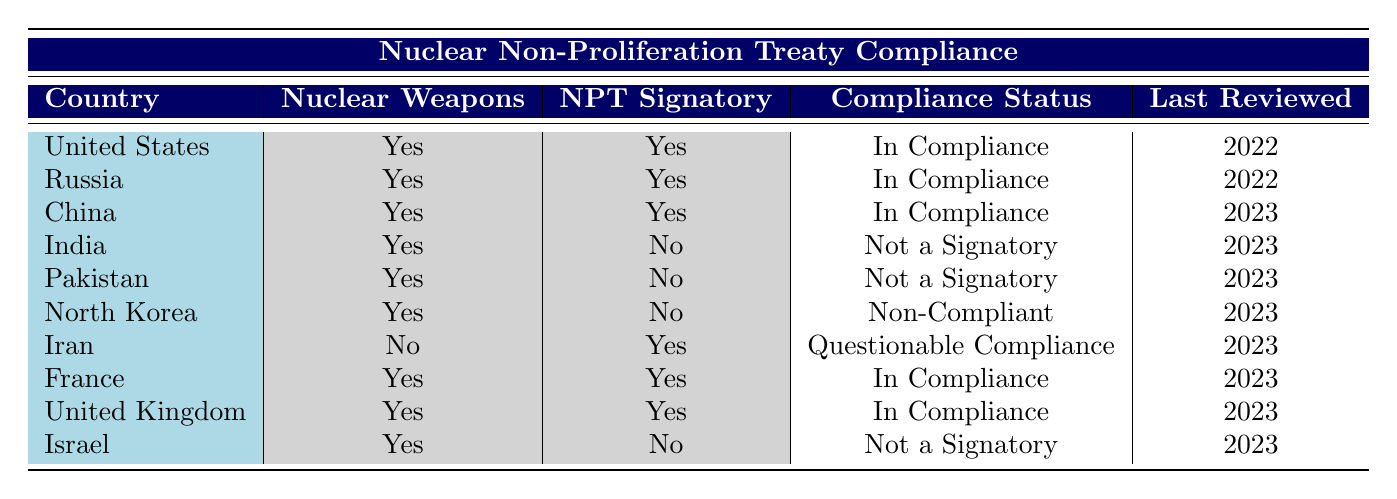What is the compliance status of the United States regarding the NPT? The table indicates that the United States is a signatory of the NPT and its compliance status is listed as "In Compliance."
Answer: In Compliance How many countries possess nuclear weapons and are signatories of the NPT? By reviewing the countries in the table, the following countries have nuclear weapons and are NPT signatories: United States, Russia, China, France, and the United Kingdom. This totals to five countries.
Answer: 5 Is North Korea compliant with the NPT? The table shows that North Korea is not a signatory of the NPT and its compliance status is "Non-Compliant." Thus, North Korea is not compliant with the treaty.
Answer: No Which country has the most recent review date and what is its compliance status? The last reviewed date for compliance status is 2023 for China, while the other 2023 reviews cover Iran, France, United Kingdom, and Israel as well. Among these, China is noted for "In Compliance." Thus, the most recent country reviewed with compliance status is China with "In Compliance."
Answer: China, In Compliance How many countries are classified as "Not a Signatory"? By examining the table, the countries India, Pakistan, and Israel are marked as "Not a Signatory." Therefore, there are three such countries.
Answer: 3 Is Iran compliant according to the table? The table provides that Iran, although a signatory of the NPT, has a compliance status labeled "Questionable Compliance," indicating it may not fully comply. Thus, it is not compliant.
Answer: No What is the average review year for countries in compliance? The compliance status "In Compliance" is attributed to five countries with the last reviewed years being 2022 for the United States and Russia and 2023 for China, France, and the United Kingdom. The sum of these years (2022 + 2022 + 2023 + 2023 + 2023) equals 10113. Dividing by 5 gives an average of 2022.6, which rounds to approximately 2023.
Answer: 2023 Which country among the NPT signatories does not possess nuclear weapons? The table specifies that Iran is the only NPT signatory listed without nuclear weapons. Therefore, Iran is the country that fits this criterion.
Answer: Iran 